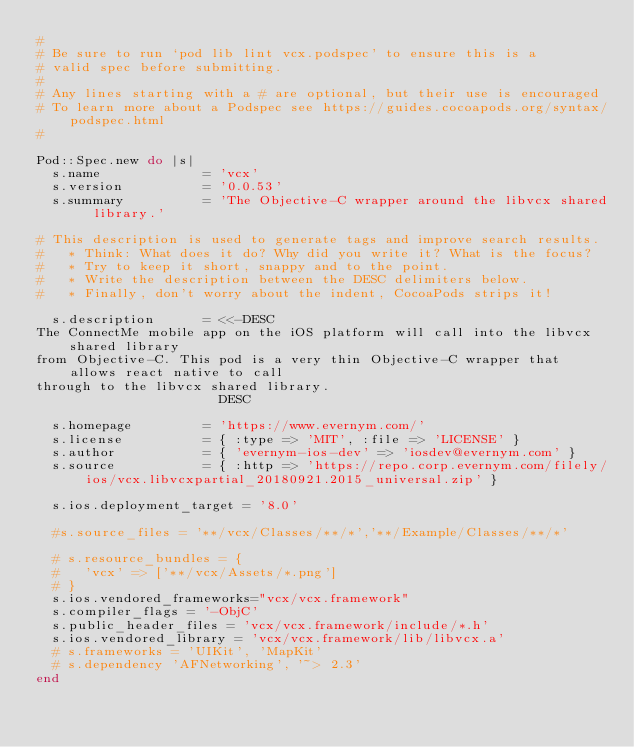<code> <loc_0><loc_0><loc_500><loc_500><_Ruby_>#
# Be sure to run `pod lib lint vcx.podspec' to ensure this is a
# valid spec before submitting.
#
# Any lines starting with a # are optional, but their use is encouraged
# To learn more about a Podspec see https://guides.cocoapods.org/syntax/podspec.html
#

Pod::Spec.new do |s|
  s.name             = 'vcx'
  s.version          = '0.0.53'
  s.summary          = 'The Objective-C wrapper around the libvcx shared library.'

# This description is used to generate tags and improve search results.
#   * Think: What does it do? Why did you write it? What is the focus?
#   * Try to keep it short, snappy and to the point.
#   * Write the description between the DESC delimiters below.
#   * Finally, don't worry about the indent, CocoaPods strips it!

  s.description      = <<-DESC
The ConnectMe mobile app on the iOS platform will call into the libvcx shared library
from Objective-C. This pod is a very thin Objective-C wrapper that allows react native to call
through to the libvcx shared library.
                       DESC

  s.homepage         = 'https://www.evernym.com/'
  s.license          = { :type => 'MIT', :file => 'LICENSE' }
  s.author           = { 'evernym-ios-dev' => 'iosdev@evernym.com' }
  s.source           = { :http => 'https://repo.corp.evernym.com/filely/ios/vcx.libvcxpartial_20180921.2015_universal.zip' }

  s.ios.deployment_target = '8.0'

  #s.source_files = '**/vcx/Classes/**/*','**/Example/Classes/**/*'

  # s.resource_bundles = {
  #   'vcx' => ['**/vcx/Assets/*.png']
  # }
  s.ios.vendored_frameworks="vcx/vcx.framework"
  s.compiler_flags = '-ObjC'
  s.public_header_files = 'vcx/vcx.framework/include/*.h'
  s.ios.vendored_library = 'vcx/vcx.framework/lib/libvcx.a'
  # s.frameworks = 'UIKit', 'MapKit'
  # s.dependency 'AFNetworking', '~> 2.3'
end</code> 